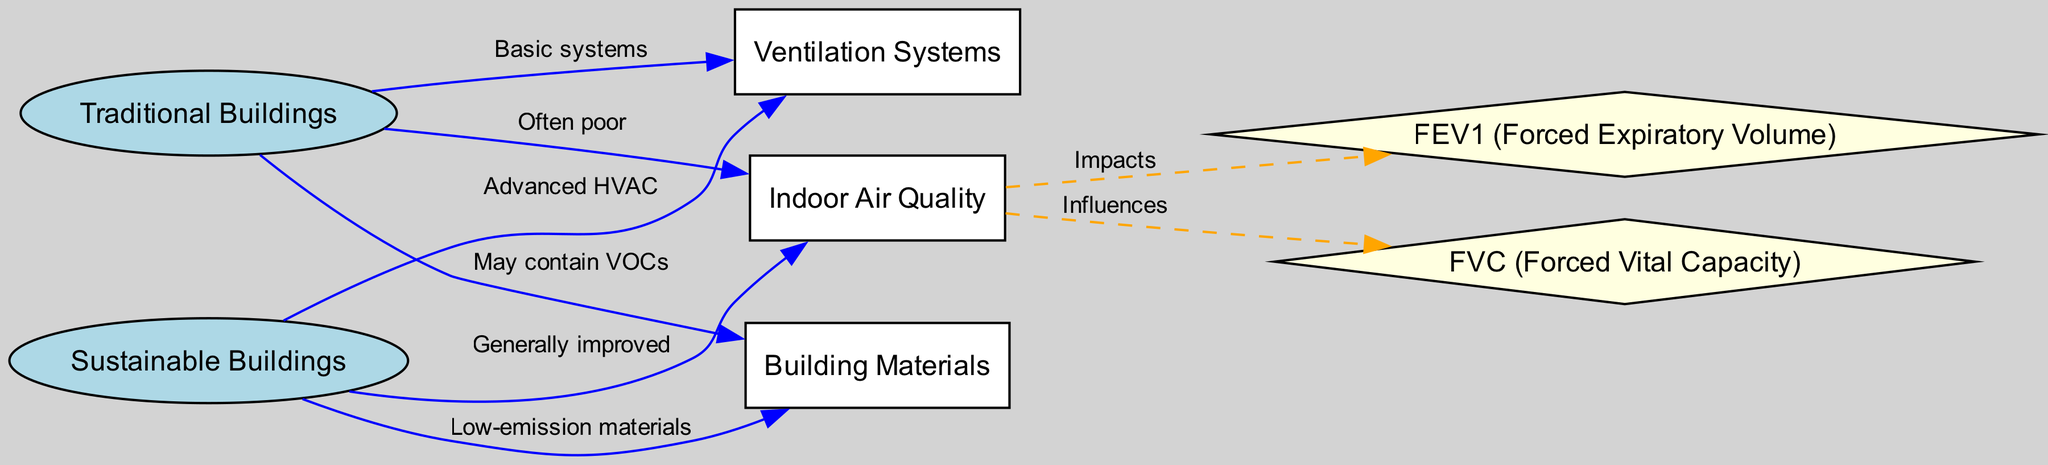What type of buildings generally have improved indoor air quality? The diagram indicates that Sustainable Buildings generally have improved indoor air quality, as indicated by the edge labeled "Generally improved" connecting Sustainable Buildings to Indoor Air Quality.
Answer: Sustainable Buildings How many types of lung function measures are indicated in the diagram? The diagram displays two measures of lung function, which are represented by the nodes FEV1 (Forced Expiratory Volume) and FVC (Forced Vital Capacity), as indicated by the number of nodes at the end of the diagram.
Answer: Two What type of ventilation systems are associated with traditional buildings? According to the diagram, traditional buildings are linked to basic systems of ventilation, as shown by the edge labeled "Basic systems" connecting Traditional Buildings to Ventilation Systems.
Answer: Basic systems Which building type is linked to low-emission materials? The diagram shows that Sustainable Buildings are associated with low-emission materials, as indicated by the edge labeled "Low-emission materials" connecting Sustainable Buildings to Building Materials.
Answer: Sustainable Buildings How does indoor air quality impact lung function as represented in the diagram? The diagram illustrates that Indoor Air Quality impacts both FEV1 and FVC, as indicated by the edges labeled "Impacts" and "Influences," showing that poorer air quality can affect measures of lung function.
Answer: Impacts both FEV1 and FVC What materials are traditional buildings likely to contain? The diagram indicates that traditional buildings may contain VOCs, as shown by the edge labeled "May contain VOCs" connecting Traditional Buildings to Building Materials.
Answer: VOCs What is the relationship between Sustainable Buildings and ventilation systems in the diagram? The relationship indicates that sustainable buildings utilize advanced HVAC systems, as illustrated by the edge labeled "Advanced HVAC" connecting Sustainable Buildings to Ventilation Systems.
Answer: Advanced HVAC Which lung function measure is influenced by indoor air quality according to the diagram? The diagram shows that both measures, FEV1 (Forced Expiratory Volume) and FVC (Forced Vital Capacity), are influenced by Indoor Air Quality, as indicated by the connecting edges.
Answer: Both FEV1 and FVC How does building design relate to respiratory health in the diagram? The diagram connects the types of buildings (traditional vs. sustainable) directly to Indoor Air Quality, which in turn influences lung function measures, highlighting the importance of sustainable architecture for respiratory health.
Answer: Directly linked through air quality impacts 